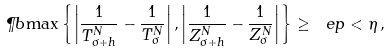Convert formula to latex. <formula><loc_0><loc_0><loc_500><loc_500>\P b { \max \left \{ \left | \frac { 1 } { T ^ { N } _ { \sigma + h } } - \frac { 1 } { T ^ { N } _ { \sigma } } \right | , \left | \frac { 1 } { Z ^ { N } _ { \sigma + h } } - \frac { 1 } { Z ^ { N } _ { \sigma } } \right | \right \} \geq \ e p } < \eta \, ,</formula> 